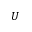Convert formula to latex. <formula><loc_0><loc_0><loc_500><loc_500>U</formula> 